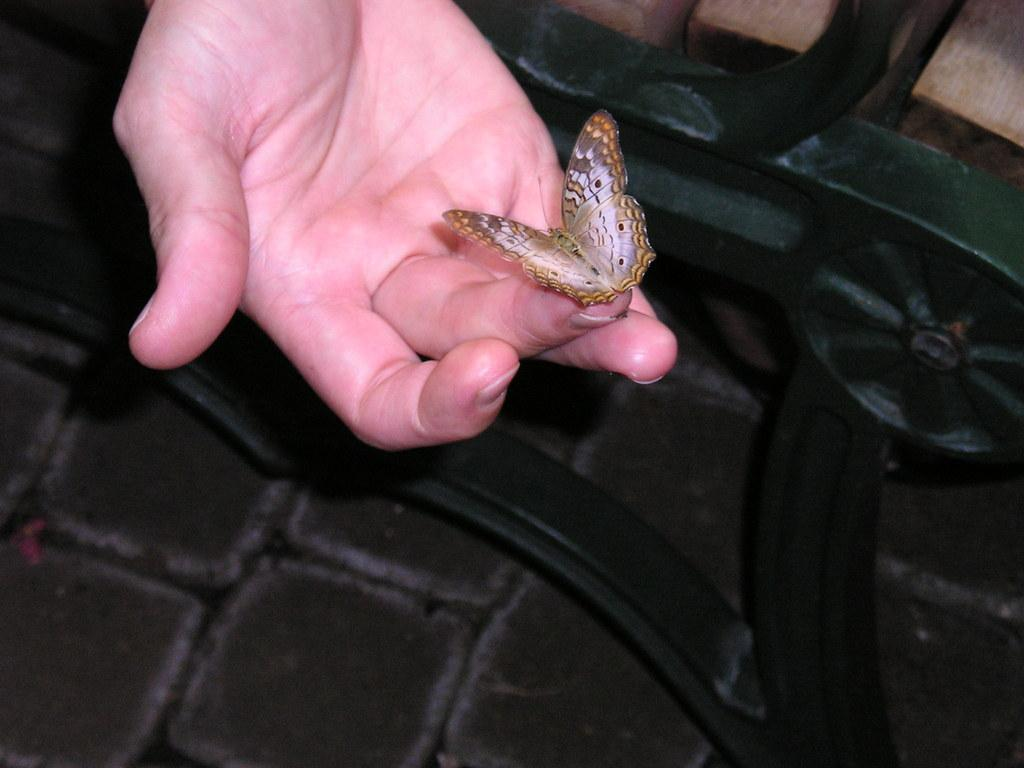What is the main subject of the image? There is a butterfly in the image. Where is the butterfly located? The butterfly is on a person's hand. What can be seen beneath the hand in the image? There is an object under the hand in the image. What type of surface is visible in the image? The floor is visible in the image. What type of soda is the farmer holding in the image? There is no farmer or soda present in the image; it features a butterfly on a person's hand. What type of pan is visible in the image? There is no pan present in the image; it features a butterfly on a person's hand. 